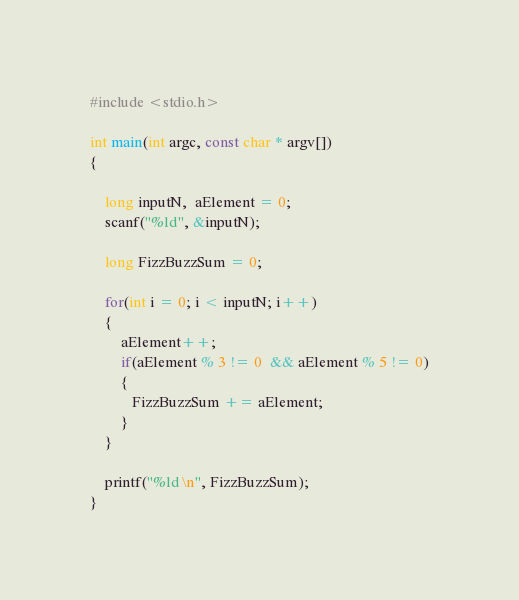Convert code to text. <code><loc_0><loc_0><loc_500><loc_500><_C_>#include <stdio.h>

int main(int argc, const char * argv[])
{

    long inputN,  aElement = 0;
    scanf("%ld", &inputN);
    
    long FizzBuzzSum = 0;
    
    for(int i = 0; i < inputN; i++)
    {
        aElement++;
        if(aElement % 3 != 0  && aElement % 5 != 0)
        {
           FizzBuzzSum += aElement;
        }
    }
    
    printf("%ld \n", FizzBuzzSum);
}</code> 